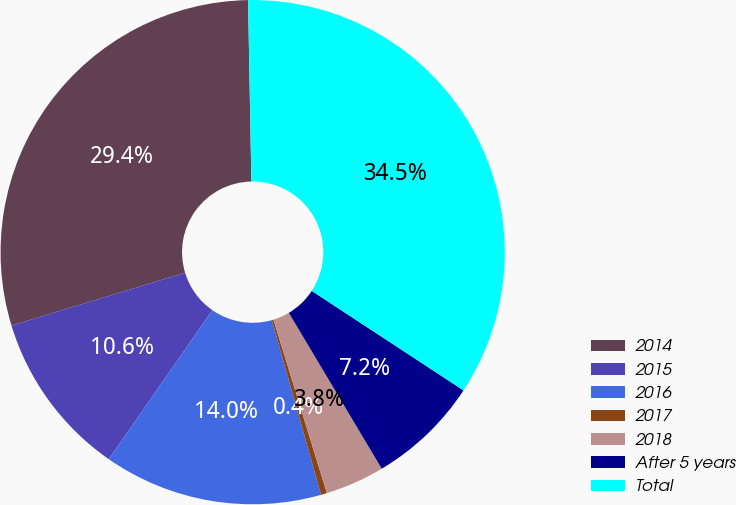Convert chart. <chart><loc_0><loc_0><loc_500><loc_500><pie_chart><fcel>2014<fcel>2015<fcel>2016<fcel>2017<fcel>2018<fcel>After 5 years<fcel>Total<nl><fcel>29.41%<fcel>10.63%<fcel>14.04%<fcel>0.38%<fcel>3.8%<fcel>7.21%<fcel>34.53%<nl></chart> 